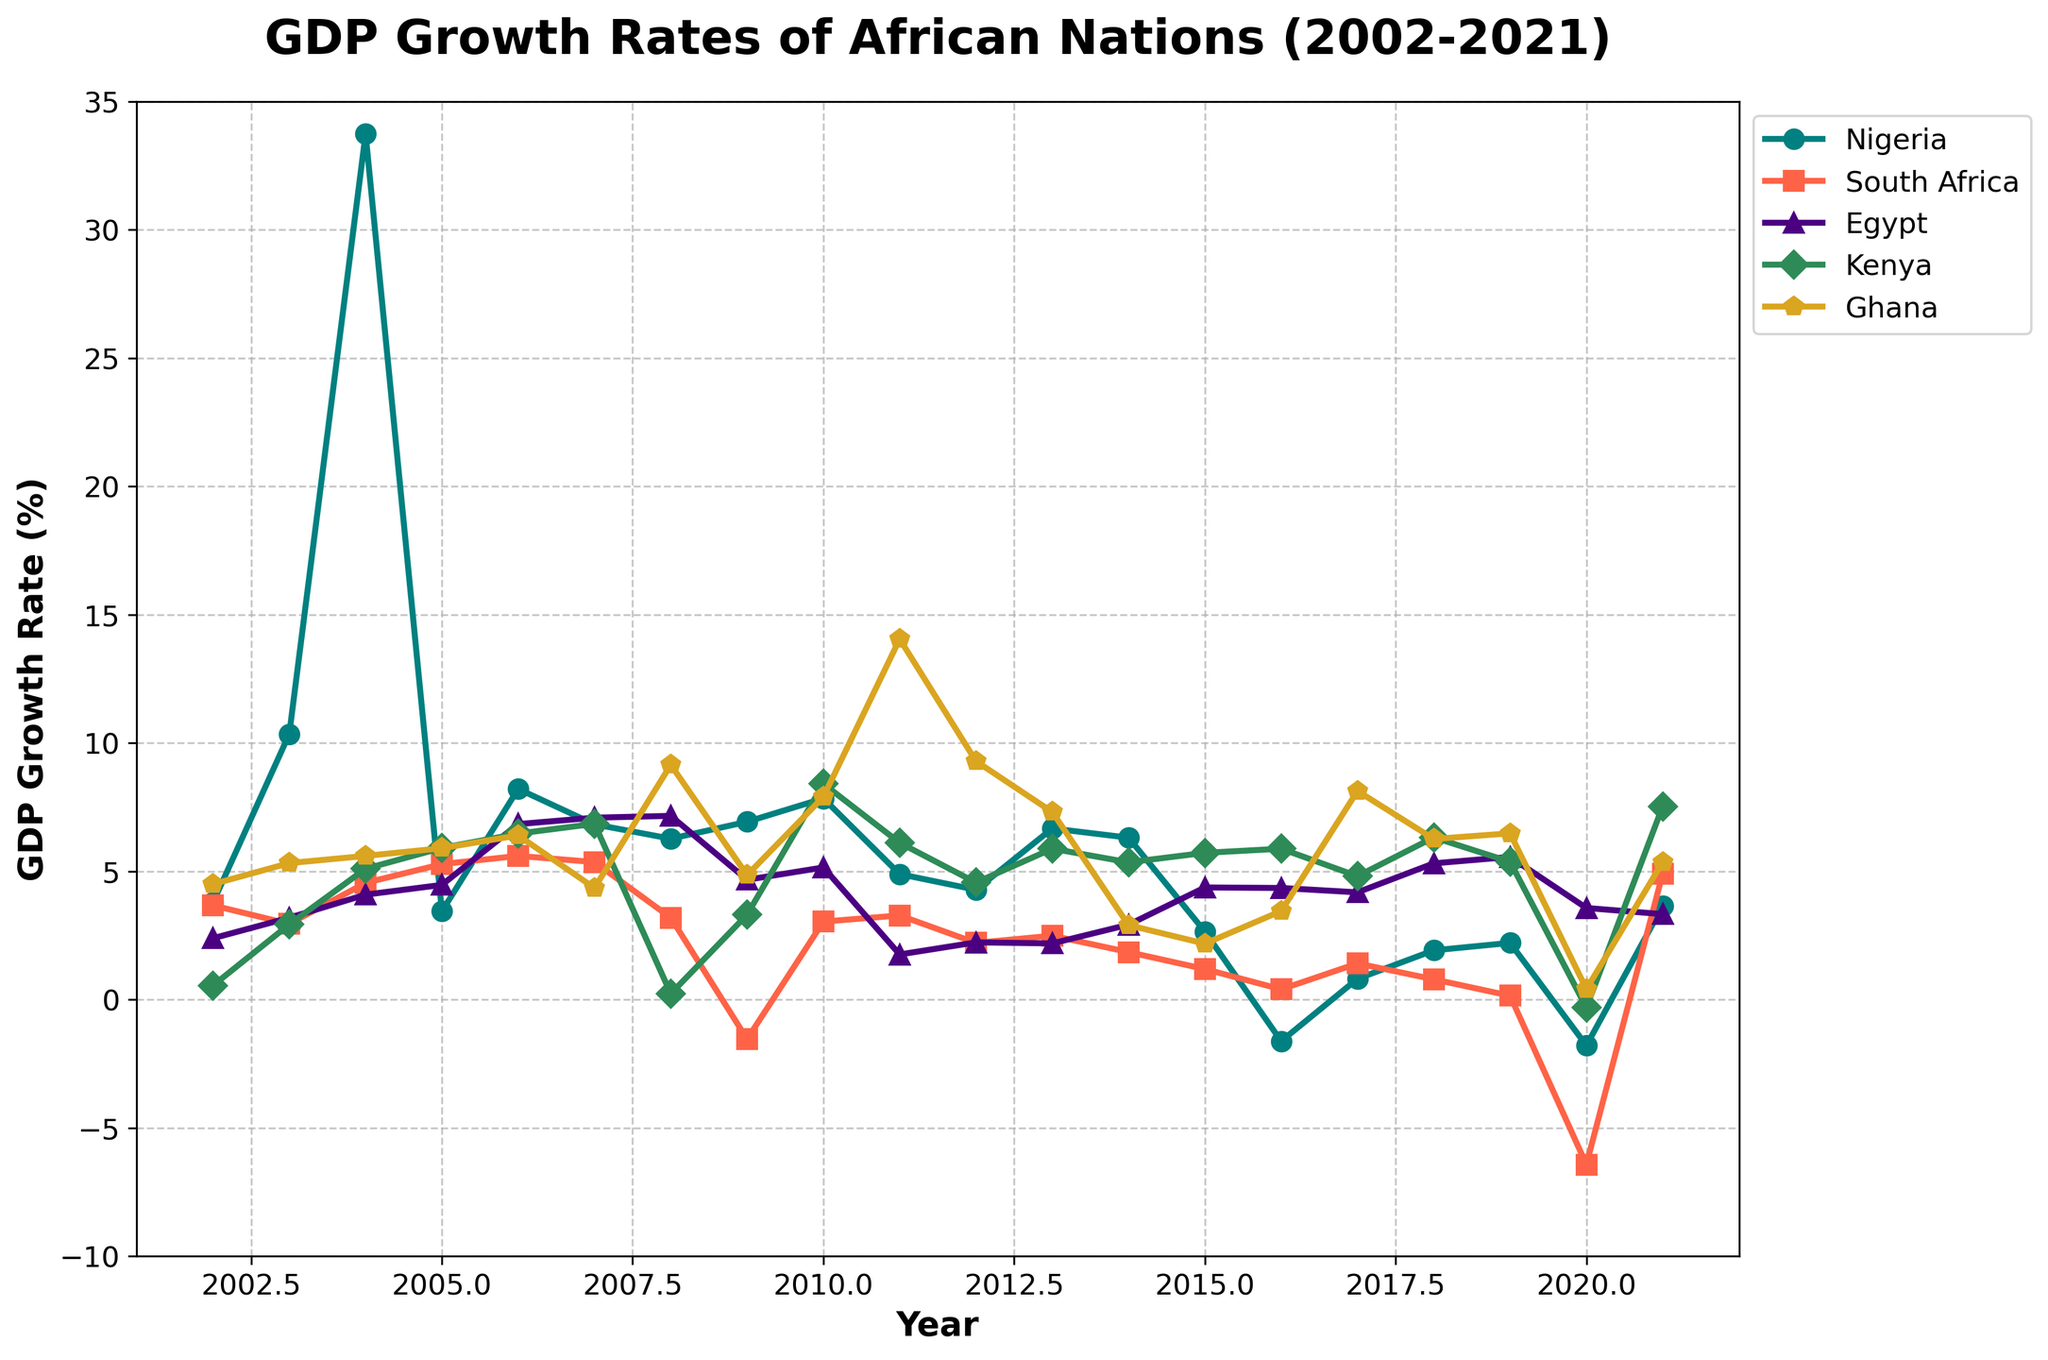What was the peak GDP growth rate for Nigeria over the period? To find Nigeria's peak GDP growth rate, observe the highest point along Nigeria's line (marked with circles). The highest point is in 2004 with a GDP growth rate of approximately 33.74%.
Answer: 33.74% Which country had the highest GDP growth rate in 2004 and what was it? Look at the plotted lines for all countries in the year 2004. Nigeria's line has the highest point, with a value of 33.74%.
Answer: Nigeria, 33.74% In which year did South Africa experience the largest negative GDP growth rate, and what was the rate? Identify the lowest point on South Africa’s line (marked with squares). The lowest point is in 2020 with a GDP growth rate of -6.43%.
Answer: 2020, -6.43% Comparing the GDP growth rates of Nigeria and Egypt in 2010, which country had a higher rate and by how much? Locate the points for Nigeria and Egypt in 2010. Nigeria has a rate of 7.84%, and Egypt has a rate of 5.15%. The difference is 7.84% - 5.15% = 2.69%.
Answer: Nigeria, 2.69% Which country had the steadiest GDP growth rate over the 20-year period and how can it be visually identified from the plot? The steadiest GDP growth rate is represented by the line with minimal fluctuations. Egypt’s line (marked with triangles) shows smaller peaks and troughs compared to others, indicating more stable growth.
Answer: Egypt How did Kenya's GDP growth rate in 2021 compare to that in 2020? Look at the points along Kenya's line (marked with diamonds) for 2020 and 2021. In 2020, the rate is approximately -0.31% and in 2021, it is 7.53%, showing an increase.
Answer: Increased by 7.84% Which country experienced the most volatility in GDP growth rate from 2002 to 2021, and how can you tell? Volatility is shown by large fluctuations in the GDP growth rate. Nigeria's line shows the largest peaks and troughs, particularly a sharp peak in 2004 and significant drops in 2016 and 2020.
Answer: Nigeria During which years did Ghana have a higher GDP growth rate than Kenya? Compare the points for Ghana and Kenya for each year. Ghana had higher rates in 2002, 2003, 2004, 2008, 2010, 2011, 2012, 2013, 2016, 2017, and 2018.
Answer: Several years What is the average GDP growth rate for Nigeria from 2015 to 2021? Add up the GDP growth rates for Nigeria from 2015 to 2021 and divide by the number of years. (2.65 - 1.62 + 0.81 + 1.92 + 2.21 - 1.79 + 3.65) / 7 = 1.26%.
Answer: 1.26% 